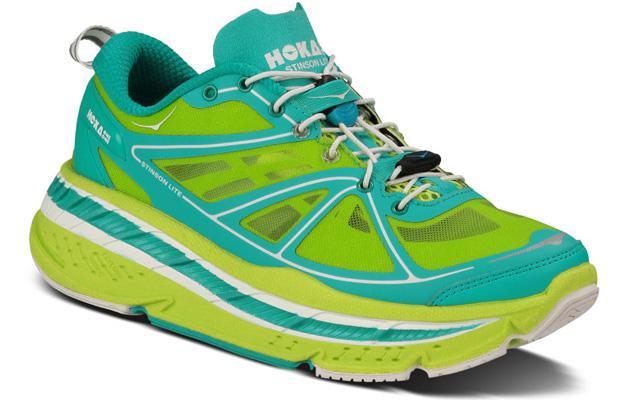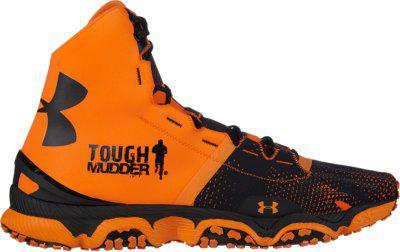The first image is the image on the left, the second image is the image on the right. Analyze the images presented: Is the assertion "Each image shows a single rightward-facing sneaker, and the combined images include lime green and aqua-blue colors, among others." valid? Answer yes or no. Yes. The first image is the image on the left, the second image is the image on the right. For the images displayed, is the sentence "The shoes in each of the images have their toes facing the right." factually correct? Answer yes or no. Yes. 